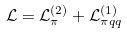Convert formula to latex. <formula><loc_0><loc_0><loc_500><loc_500>\mathcal { L } = \mathcal { L } _ { \pi } ^ { ( 2 ) } + \mathcal { L } _ { \pi q q } ^ { ( 1 ) }</formula> 